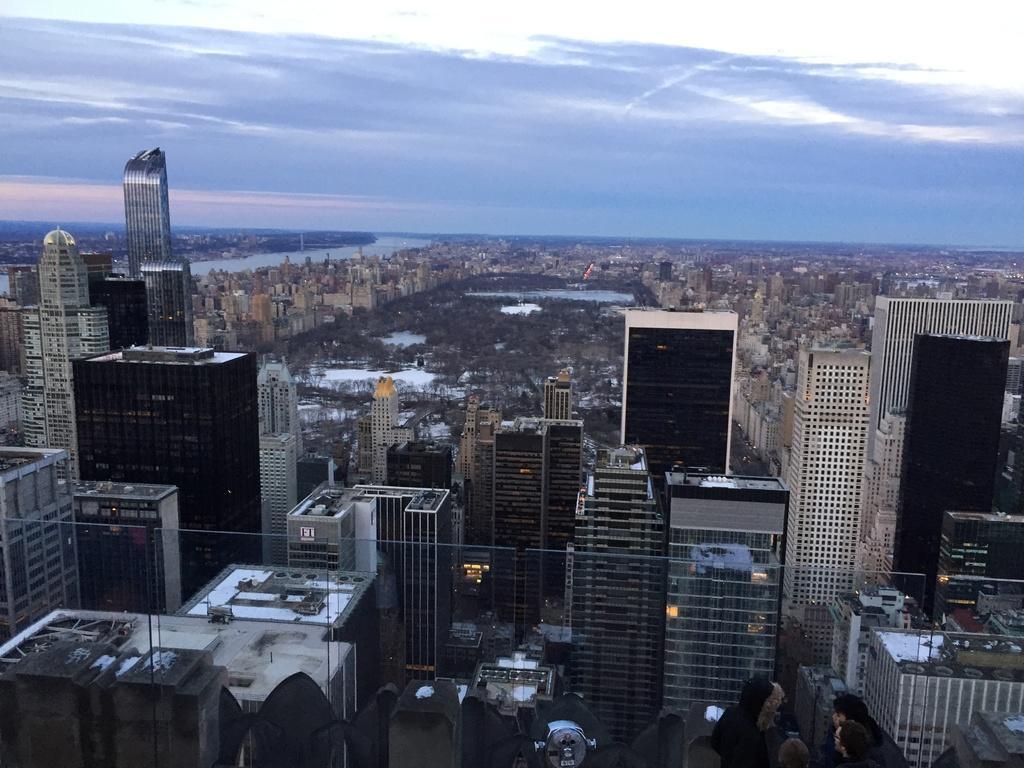How would you summarize this image in a sentence or two? We can see buildings, glass and there are people. We can see trees, water and sky with clouds. 